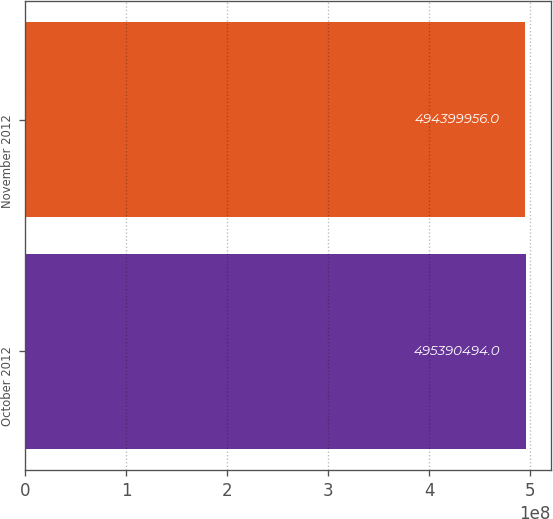Convert chart to OTSL. <chart><loc_0><loc_0><loc_500><loc_500><bar_chart><fcel>October 2012<fcel>November 2012<nl><fcel>4.9539e+08<fcel>4.944e+08<nl></chart> 